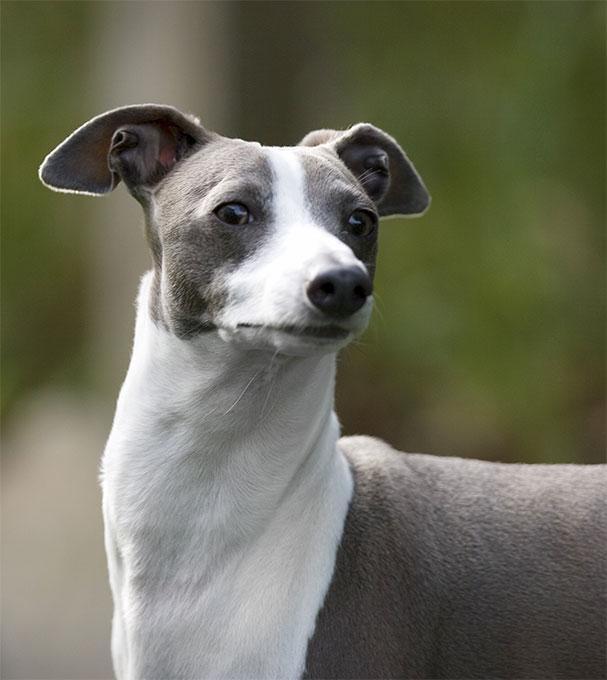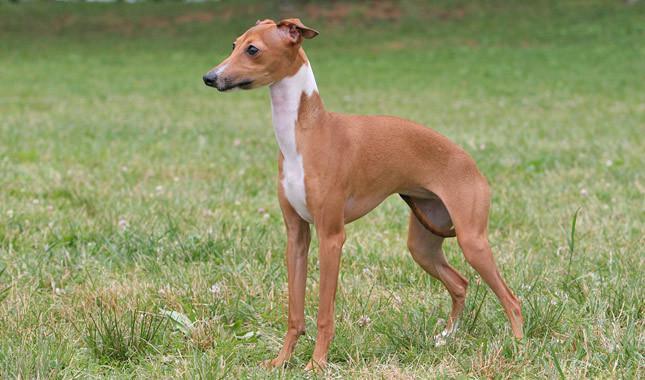The first image is the image on the left, the second image is the image on the right. Given the left and right images, does the statement "The dog in the right image wears a collar." hold true? Answer yes or no. No. 